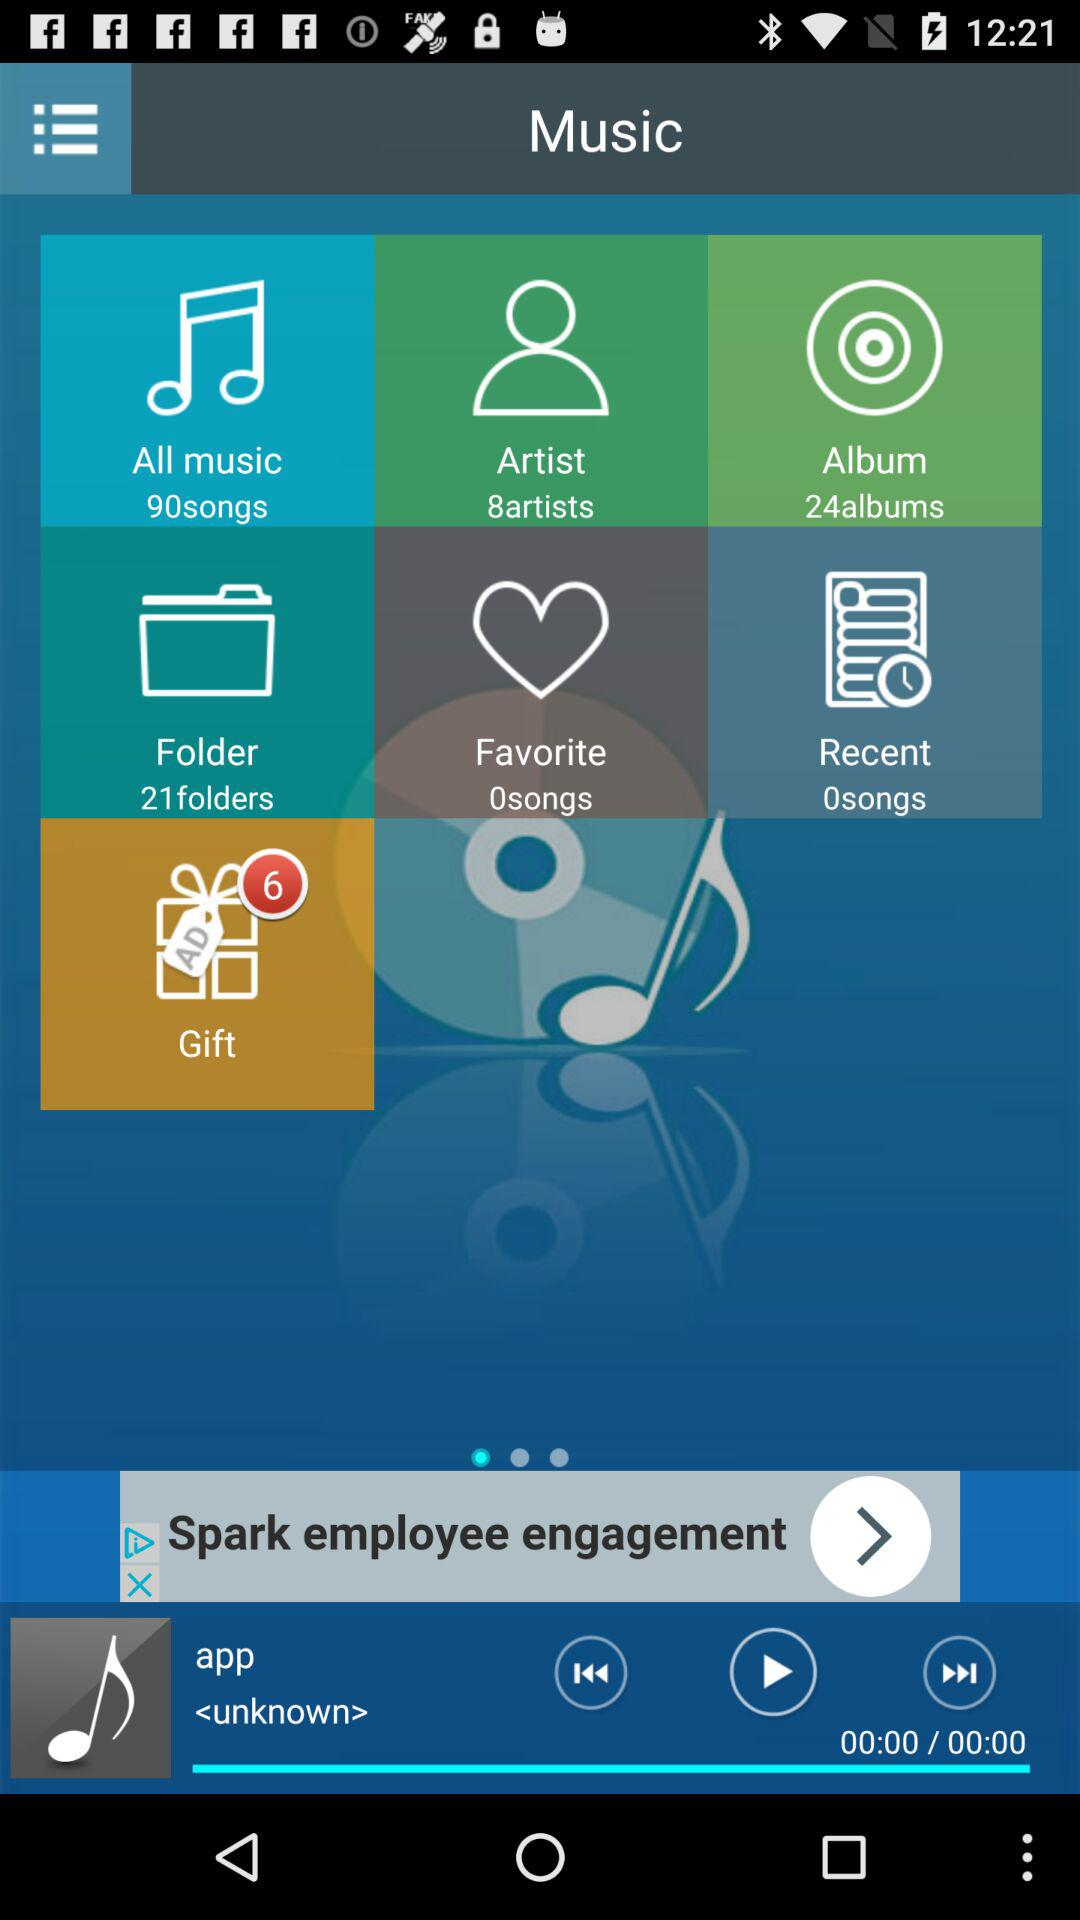How many songs are present in "All music"? There are 90 songs. 